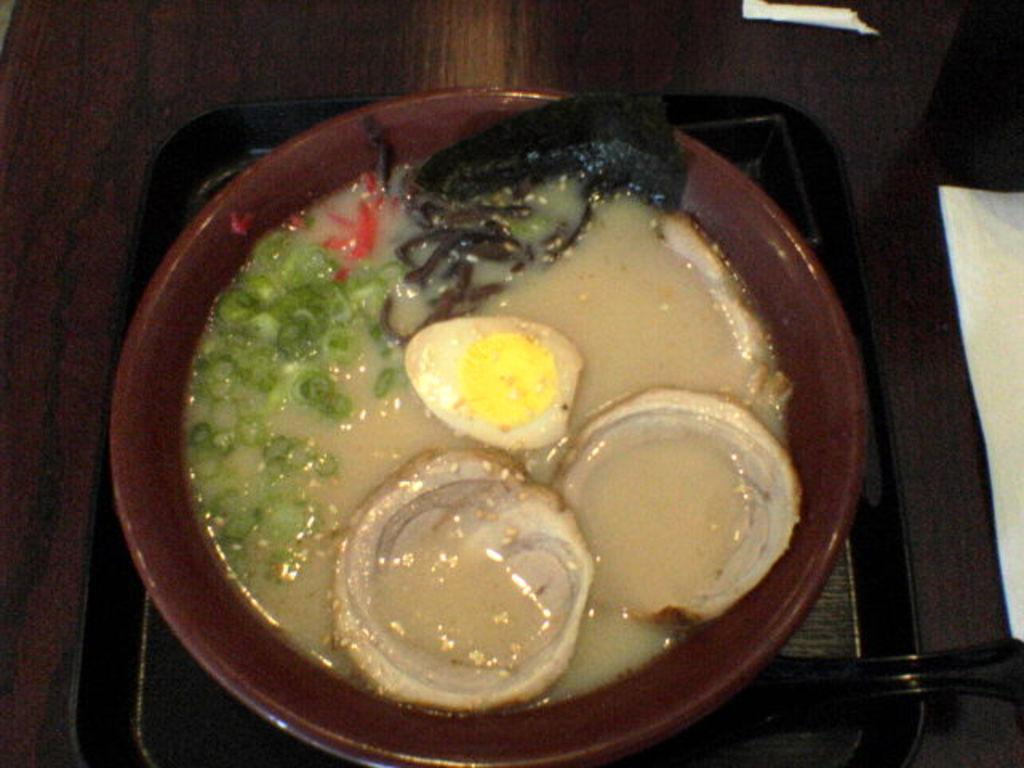What piece of furniture is present in the image? There is a table in the image. What is placed on the table? There are papers and a tray on the table. What is on the tray? There is a bowl on the tray. What is inside the bowl? The bowl contains food. Can you see the cabbage smiling in the image? There is no cabbage present in the image, and even if there were, cabbage cannot smile as it is a vegetable. 